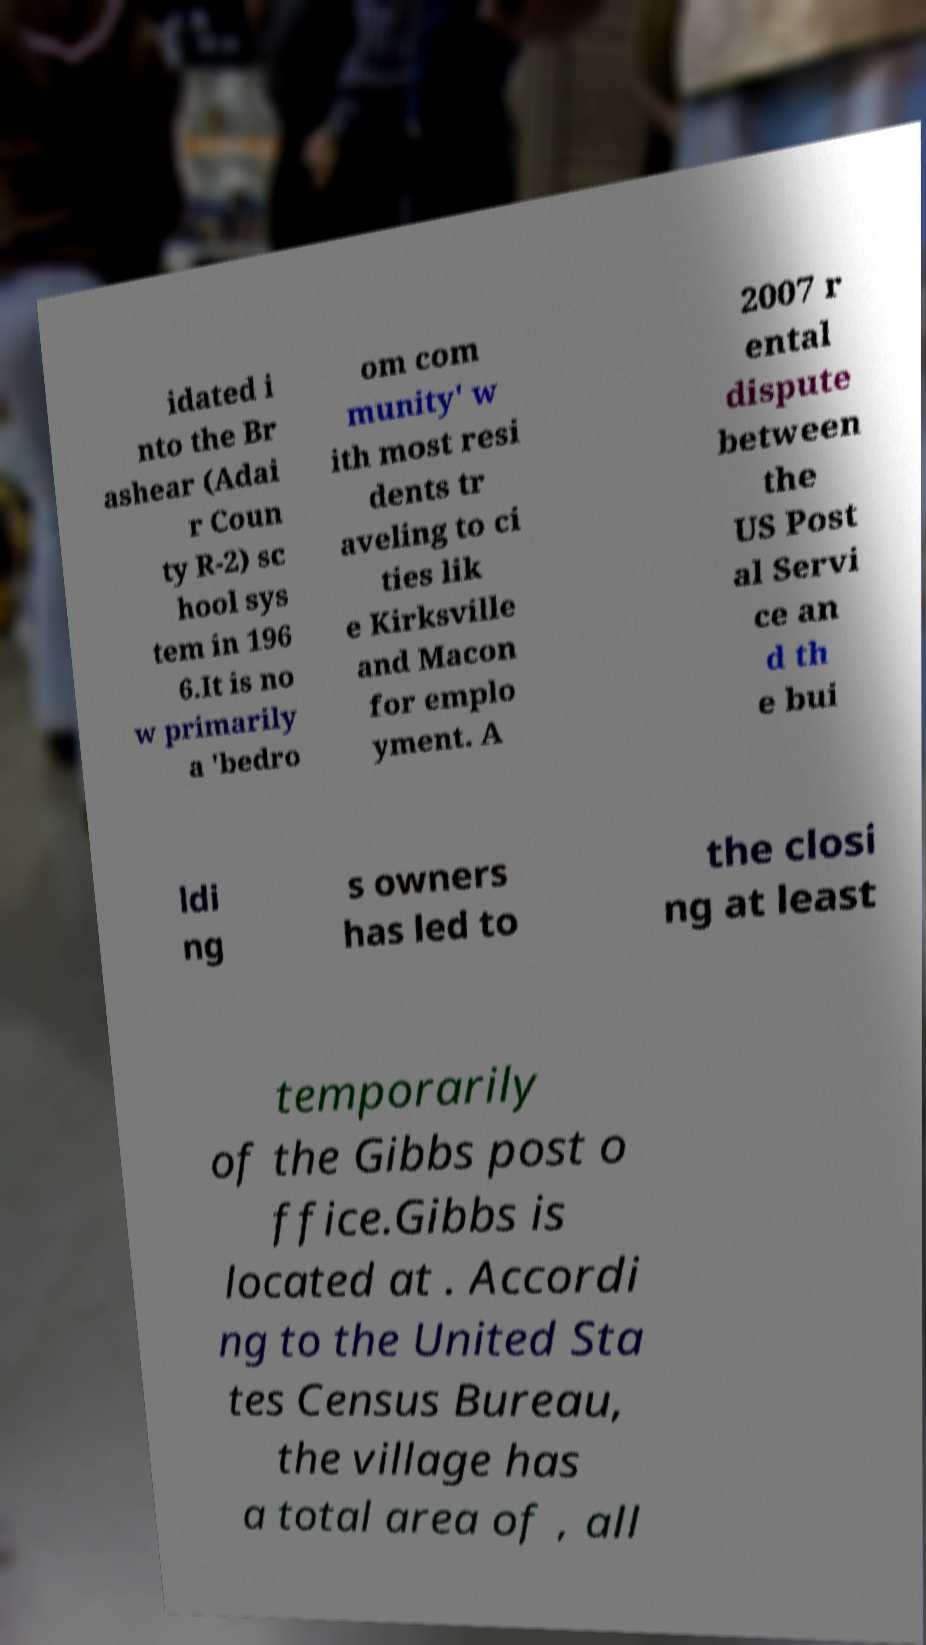Please read and relay the text visible in this image. What does it say? idated i nto the Br ashear (Adai r Coun ty R-2) sc hool sys tem in 196 6.It is no w primarily a 'bedro om com munity' w ith most resi dents tr aveling to ci ties lik e Kirksville and Macon for emplo yment. A 2007 r ental dispute between the US Post al Servi ce an d th e bui ldi ng s owners has led to the closi ng at least temporarily of the Gibbs post o ffice.Gibbs is located at . Accordi ng to the United Sta tes Census Bureau, the village has a total area of , all 